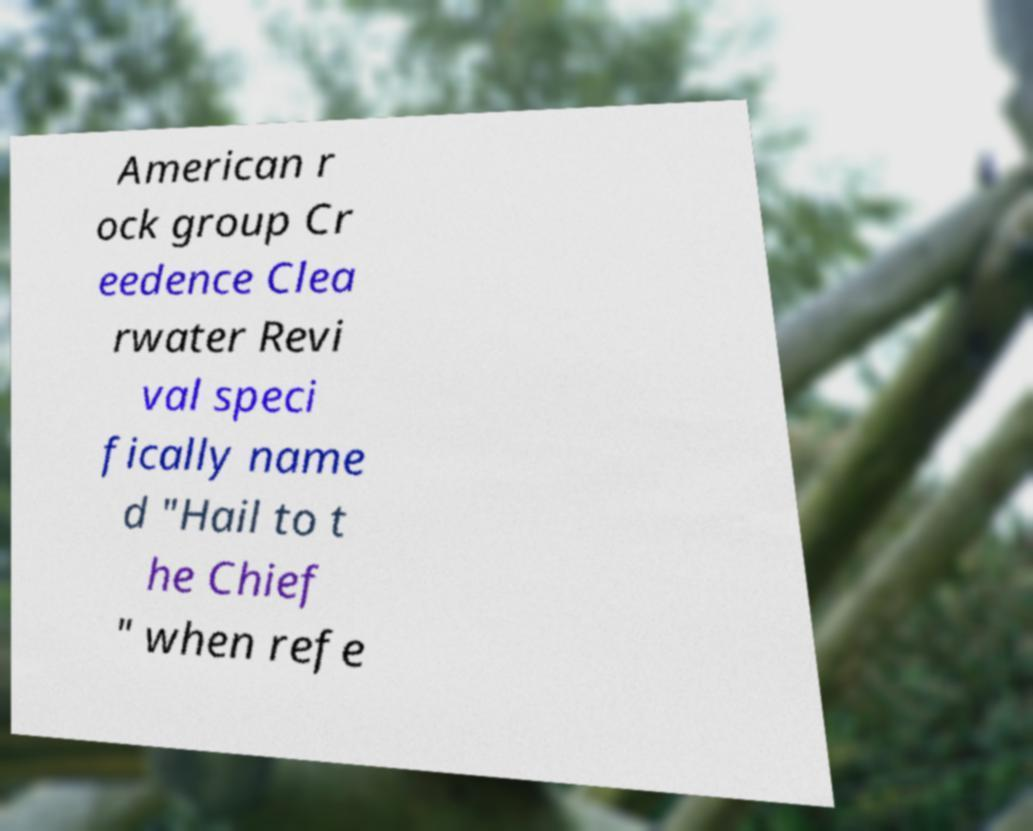Could you assist in decoding the text presented in this image and type it out clearly? American r ock group Cr eedence Clea rwater Revi val speci fically name d "Hail to t he Chief " when refe 